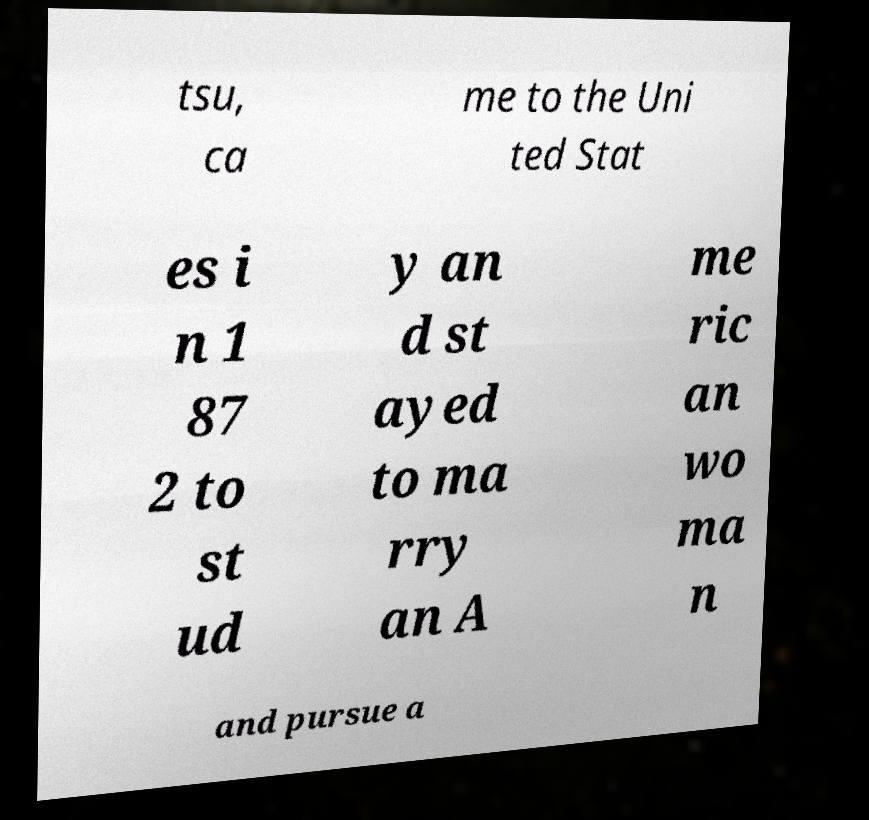Can you read and provide the text displayed in the image?This photo seems to have some interesting text. Can you extract and type it out for me? tsu, ca me to the Uni ted Stat es i n 1 87 2 to st ud y an d st ayed to ma rry an A me ric an wo ma n and pursue a 